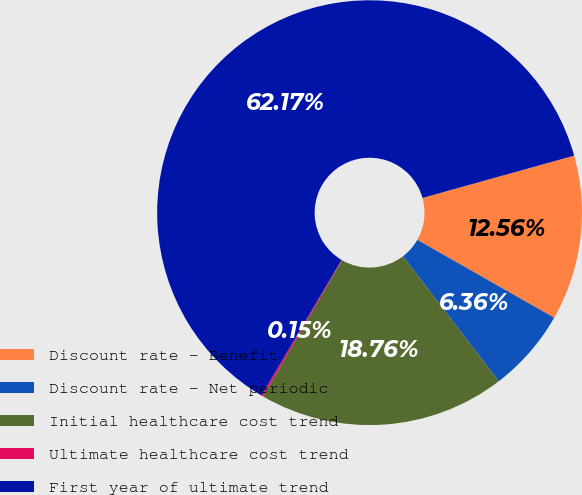Convert chart to OTSL. <chart><loc_0><loc_0><loc_500><loc_500><pie_chart><fcel>Discount rate - Benefit<fcel>Discount rate - Net periodic<fcel>Initial healthcare cost trend<fcel>Ultimate healthcare cost trend<fcel>First year of ultimate trend<nl><fcel>12.56%<fcel>6.36%<fcel>18.76%<fcel>0.15%<fcel>62.17%<nl></chart> 